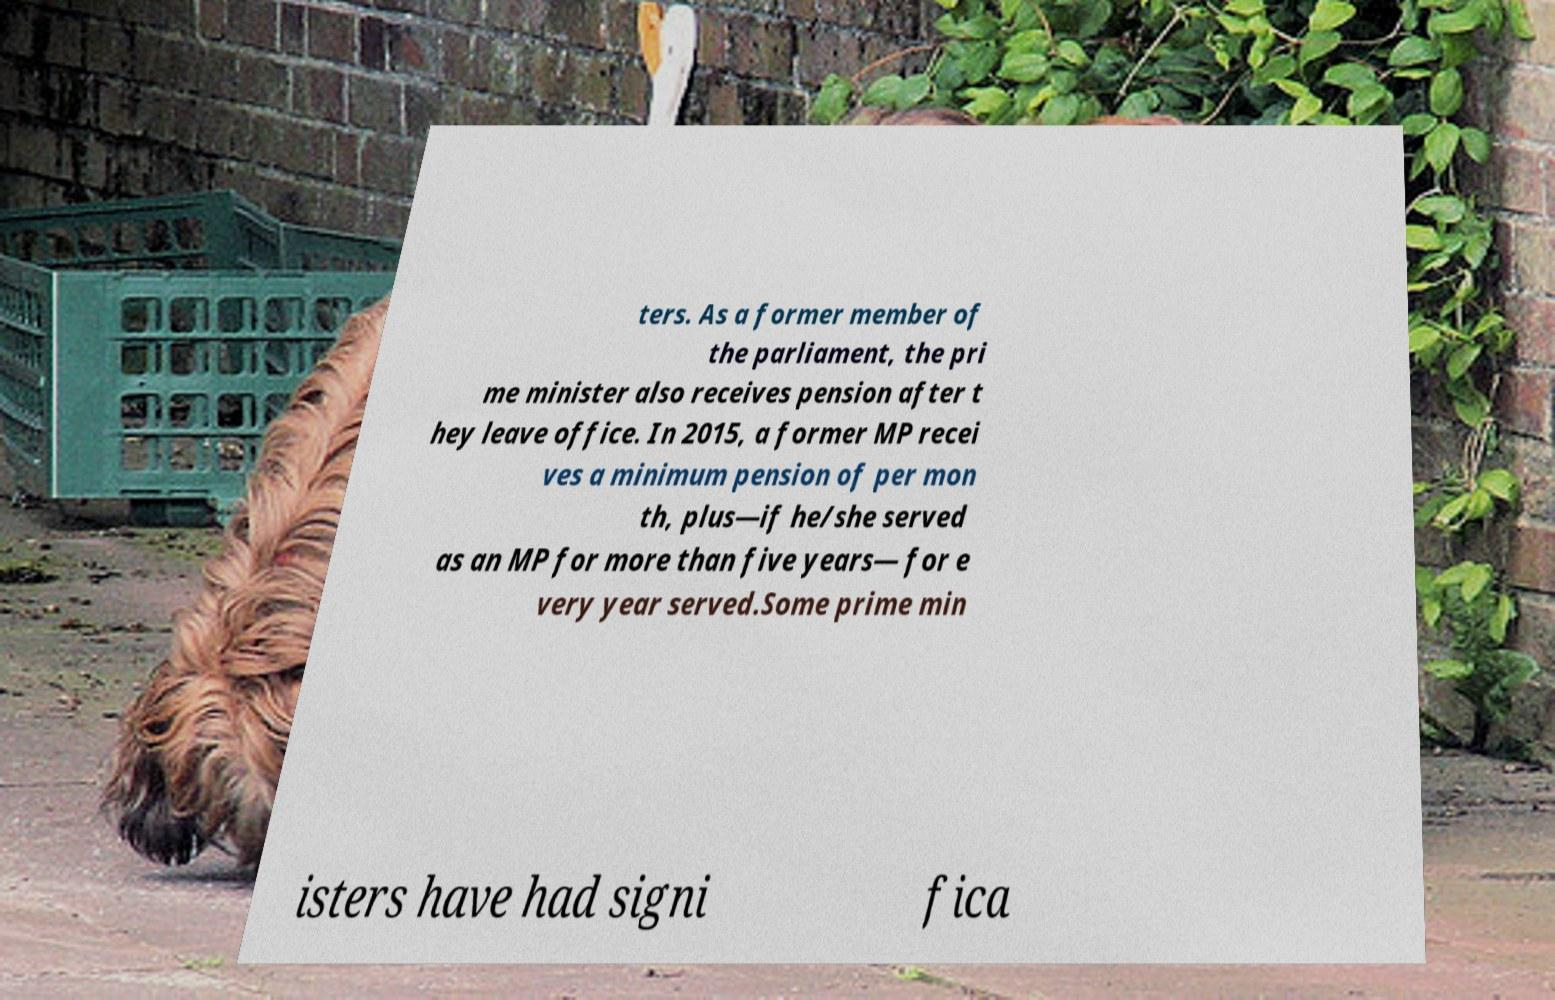Could you assist in decoding the text presented in this image and type it out clearly? ters. As a former member of the parliament, the pri me minister also receives pension after t hey leave office. In 2015, a former MP recei ves a minimum pension of per mon th, plus—if he/she served as an MP for more than five years— for e very year served.Some prime min isters have had signi fica 